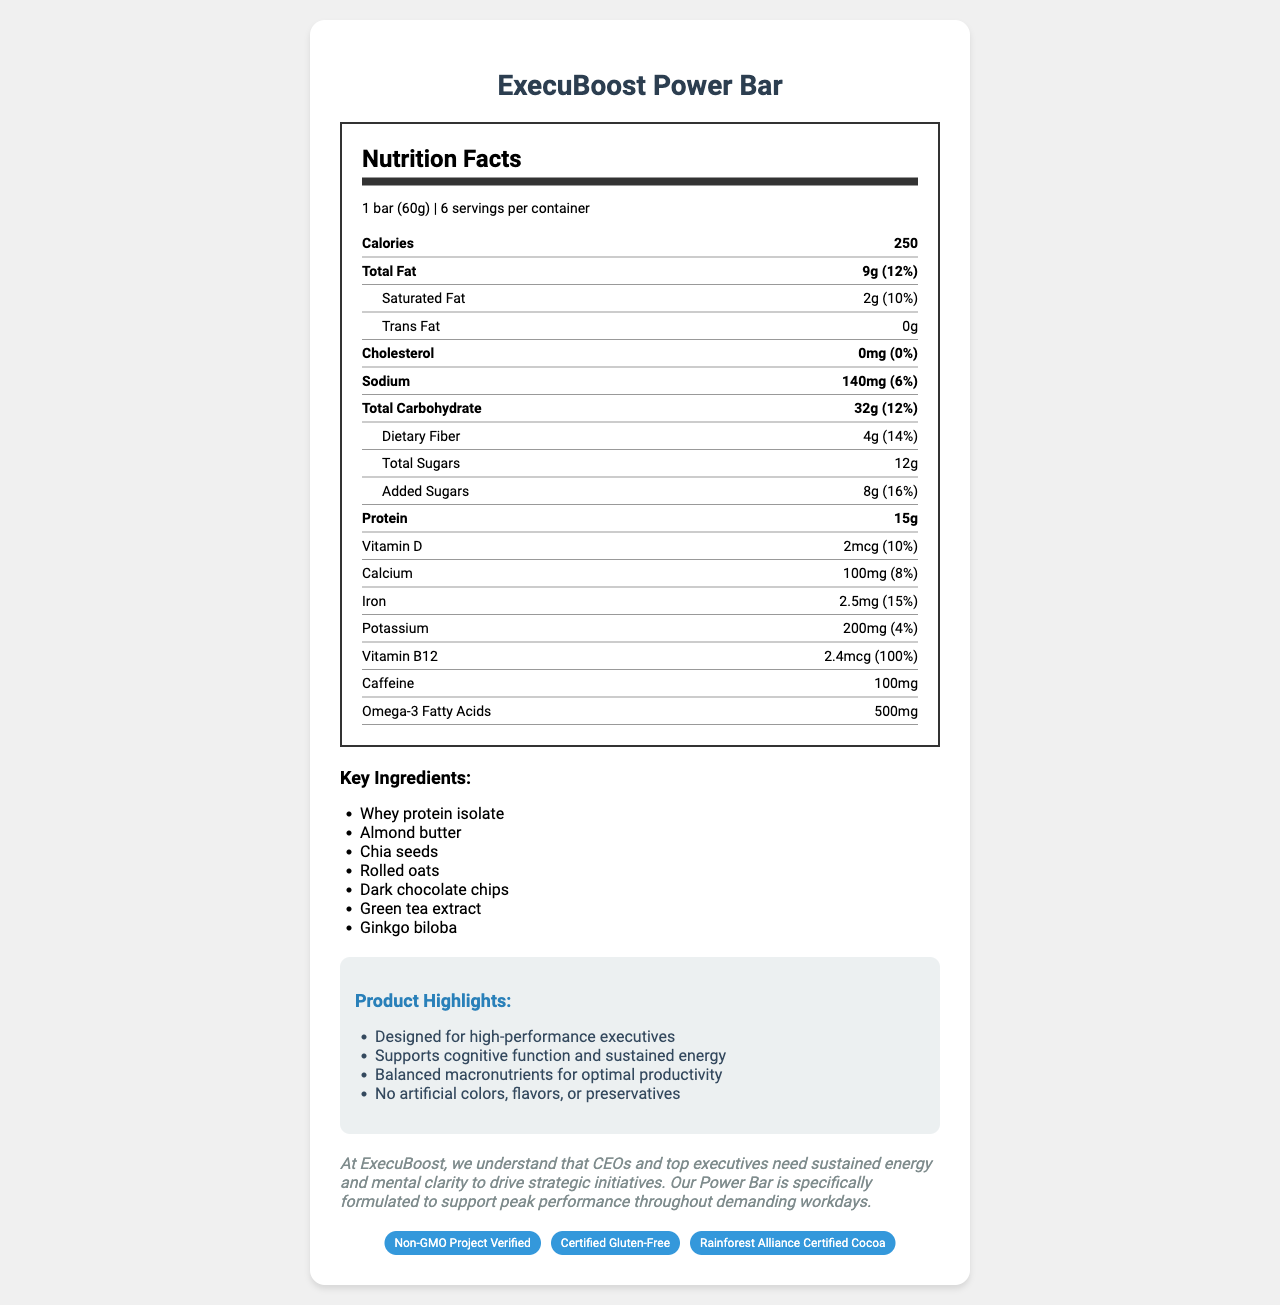what is the total fat content in one serving? The nutrition label shows Total Fat as 9g per serving.
Answer: 9g how many calories are in one bar of the ExecuBoost Power Bar? The nutrition label explicitly states that one serving, which is one bar, contains 250 calories.
Answer: 250 what is the percentage of daily value for dietary fiber? The nutrition label shows dietary fiber as 4g with a 14% daily value.
Answer: 14% what are the key ingredients listed? The document lists these ingredients under the "Key Ingredients" section.
Answer: Whey protein isolate, Almond butter, Chia seeds, Rolled oats, Dark chocolate chips, Green tea extract, Ginkgo biloba how much protein is in one serving of the energy bar? The nutrition label indicates that one serving contains 15g of protein.
Answer: 15g which certification seals are shown on the document? A. Fair Trade, Gluten-Free, Certified Organic B. Non-GMO Project Verified, Certified Gluten-Free, Rainforest Alliance Certified Cocoa C. USDA Organic, Certified Vegan, Non-GMO Project Verified The document shows the seals for Non-GMO Project Verified, Certified Gluten-Free, and Rainforest Alliance Certified Cocoa.
Answer: B what allergens are associated with this energy bar? A. Milk, Almonds, Soy B. Peanuts, Milk, Soy C. Milk, Almonds, Peanuts The allergen section lists "Contains milk, almonds, and soy."
Answer: A does the ExecuBoost Power Bar contain any cholesterol? The nutrition facts specifically state 0mg of cholesterol and 0% daily value.
Answer: No summarize the main idea of the ExecuBoost Power Bar document. The document details the product's nutritional information, key ingredients, certification seals, and its focus on supporting high-performance executives.
Answer: The ExecuBoost Power Bar is designed for high-performance executives, offering balanced macronutrients, sustained energy, and cognitive support, free of artificial preservatives, and assured by several certification seals. how much caffeine is included in each bar? The nutrition label indicates that each bar contains 100mg of caffeine.
Answer: 100mg what is the daily value percentage for iron? The nutrition label lists iron as having a daily value of 15%.
Answer: 15% is there any information about how the energy bar might affect people with peanut allergies? The allergens section mentions that it's manufactured in a facility that also processes peanuts, which may be a concern for people with peanut allergies.
Answer: Yes what is the serving size for the ExecuBoost Power Bar? The nutrition facts list the serving size as 1 bar (60g).
Answer: 1 bar (60g) how much added sugar does the energy bar contain? The nutrition label notes that the bar contains 8g of added sugars with a 16% daily value.
Answer: 8g why is the power bar specifically formulated? A. For athletes B. For children C. For high-performance executives D. For the elderly The document explicitly states that the bar is designed for high-performance executives.
Answer: C can you determine the exact amount of green tea extract in the energy bar from the document? The document lists green tea extract as a key ingredient but does not provide its specific quantity in the bar.
Answer: Not enough information 